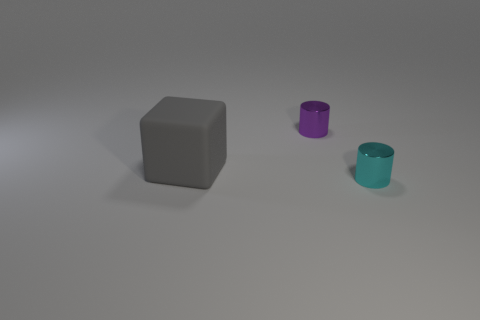Add 2 tiny shiny cylinders. How many objects exist? 5 Subtract all cubes. How many objects are left? 2 Subtract 0 gray cylinders. How many objects are left? 3 Subtract all tiny purple metal cylinders. Subtract all big objects. How many objects are left? 1 Add 2 purple metallic cylinders. How many purple metallic cylinders are left? 3 Add 3 large yellow rubber cylinders. How many large yellow rubber cylinders exist? 3 